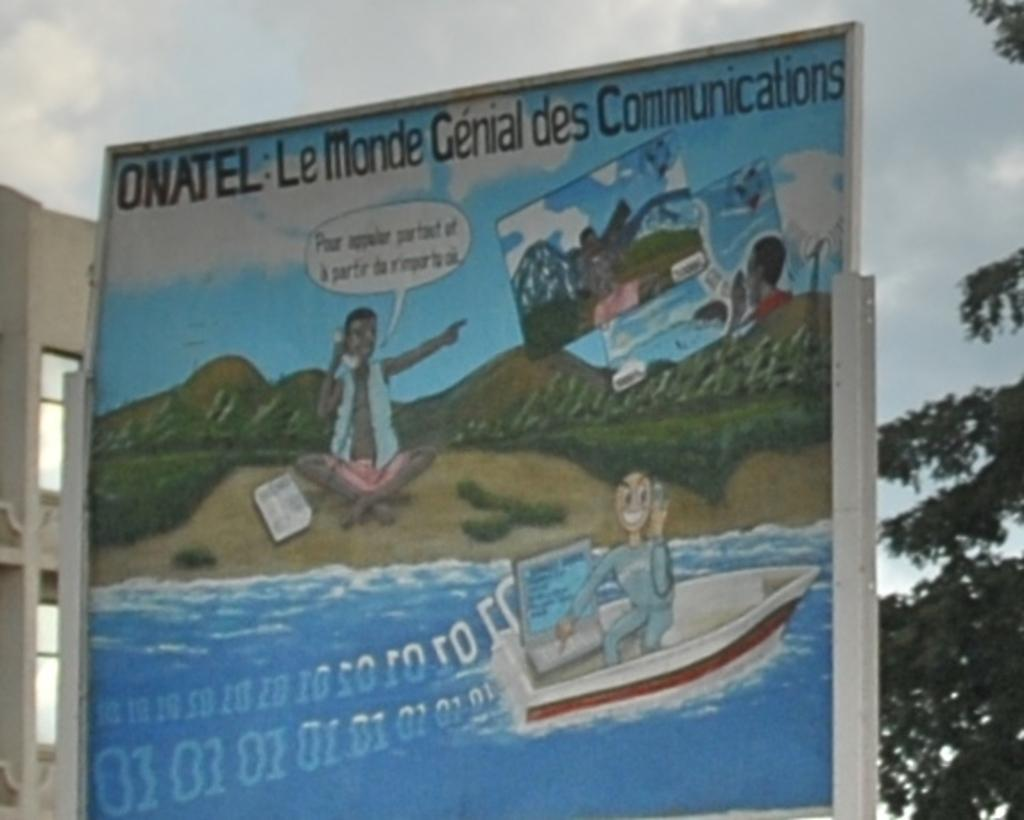<image>
Offer a succinct explanation of the picture presented. sign that has someone in boat using a laptop, someone on shore using a phone pointing at someone else and top of sign has ONATEL: LeMonde Genial des Communications 